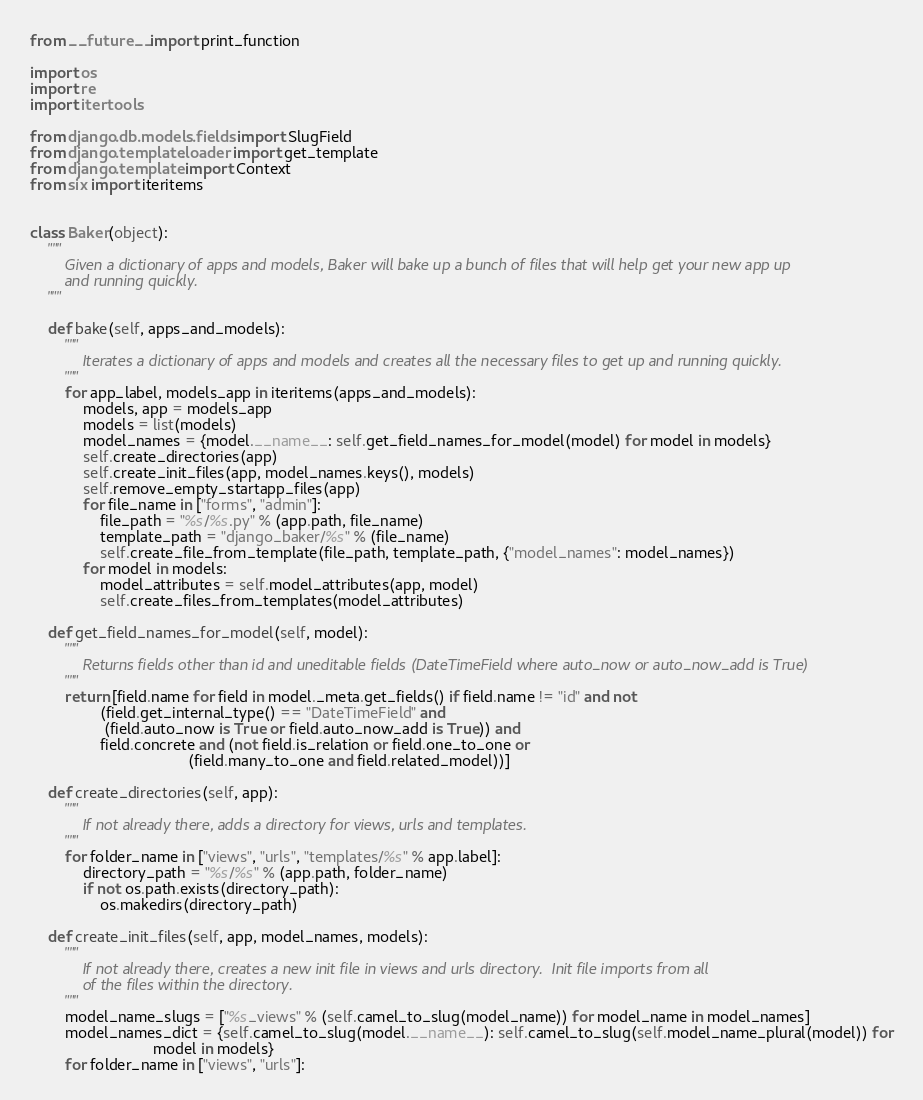<code> <loc_0><loc_0><loc_500><loc_500><_Python_>from __future__ import print_function

import os
import re
import itertools

from django.db.models.fields import SlugField
from django.template.loader import get_template
from django.template import Context
from six import iteritems


class Baker(object):
    """
        Given a dictionary of apps and models, Baker will bake up a bunch of files that will help get your new app up
        and running quickly.
    """

    def bake(self, apps_and_models):
        """
            Iterates a dictionary of apps and models and creates all the necessary files to get up and running quickly.
        """
        for app_label, models_app in iteritems(apps_and_models):
            models, app = models_app
            models = list(models)
            model_names = {model.__name__: self.get_field_names_for_model(model) for model in models}
            self.create_directories(app)
            self.create_init_files(app, model_names.keys(), models)
            self.remove_empty_startapp_files(app)
            for file_name in ["forms", "admin"]:
                file_path = "%s/%s.py" % (app.path, file_name)
                template_path = "django_baker/%s" % (file_name)
                self.create_file_from_template(file_path, template_path, {"model_names": model_names})
            for model in models:
                model_attributes = self.model_attributes(app, model)
                self.create_files_from_templates(model_attributes)

    def get_field_names_for_model(self, model):
        """
            Returns fields other than id and uneditable fields (DateTimeField where auto_now or auto_now_add is True)
        """
        return [field.name for field in model._meta.get_fields() if field.name != "id" and not
                (field.get_internal_type() == "DateTimeField" and
                 (field.auto_now is True or field.auto_now_add is True)) and
                field.concrete and (not field.is_relation or field.one_to_one or
                                    (field.many_to_one and field.related_model))]

    def create_directories(self, app):
        """
            If not already there, adds a directory for views, urls and templates.
        """
        for folder_name in ["views", "urls", "templates/%s" % app.label]:
            directory_path = "%s/%s" % (app.path, folder_name)
            if not os.path.exists(directory_path):
                os.makedirs(directory_path)

    def create_init_files(self, app, model_names, models):
        """
            If not already there, creates a new init file in views and urls directory.  Init file imports from all
            of the files within the directory.
        """
        model_name_slugs = ["%s_views" % (self.camel_to_slug(model_name)) for model_name in model_names]
        model_names_dict = {self.camel_to_slug(model.__name__): self.camel_to_slug(self.model_name_plural(model)) for
                            model in models}
        for folder_name in ["views", "urls"]:</code> 